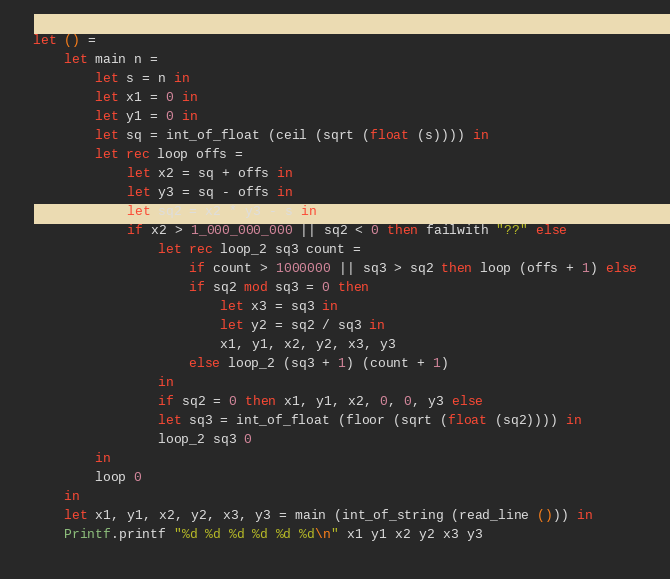Convert code to text. <code><loc_0><loc_0><loc_500><loc_500><_OCaml_>let () =
    let main n =
        let s = n in
        let x1 = 0 in
        let y1 = 0 in
        let sq = int_of_float (ceil (sqrt (float (s)))) in
        let rec loop offs =
            let x2 = sq + offs in
            let y3 = sq - offs in
            let sq2 = x2 * y3 - s in
            if x2 > 1_000_000_000 || sq2 < 0 then failwith "??" else
                let rec loop_2 sq3 count =
                    if count > 1000000 || sq3 > sq2 then loop (offs + 1) else
                    if sq2 mod sq3 = 0 then
                        let x3 = sq3 in
                        let y2 = sq2 / sq3 in
                        x1, y1, x2, y2, x3, y3
                    else loop_2 (sq3 + 1) (count + 1)
                in
                if sq2 = 0 then x1, y1, x2, 0, 0, y3 else
                let sq3 = int_of_float (floor (sqrt (float (sq2)))) in
                loop_2 sq3 0
        in
        loop 0
    in
    let x1, y1, x2, y2, x3, y3 = main (int_of_string (read_line ())) in
    Printf.printf "%d %d %d %d %d %d\n" x1 y1 x2 y2 x3 y3</code> 